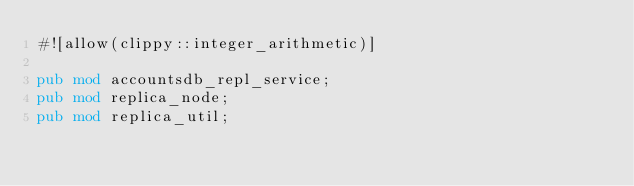Convert code to text. <code><loc_0><loc_0><loc_500><loc_500><_Rust_>#![allow(clippy::integer_arithmetic)]

pub mod accountsdb_repl_service;
pub mod replica_node;
pub mod replica_util;</code> 